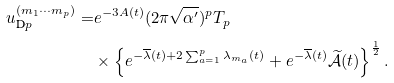<formula> <loc_0><loc_0><loc_500><loc_500>u _ { \text {D} p } ^ { ( m _ { 1 } \cdots m _ { p } ) } = & e ^ { - 3 A ( t ) } ( 2 \pi \sqrt { \alpha ^ { \prime } } ) ^ { p } T _ { p } \\ & \times \left \{ e ^ { - \overline { \lambda } ( t ) + 2 \sum _ { a = 1 } ^ { p } \lambda _ { m _ { a } } ( t ) } + e ^ { - \overline { \lambda } ( t ) } \widetilde { \mathcal { A } } ( t ) \right \} ^ { \frac { 1 } { 2 } } .</formula> 